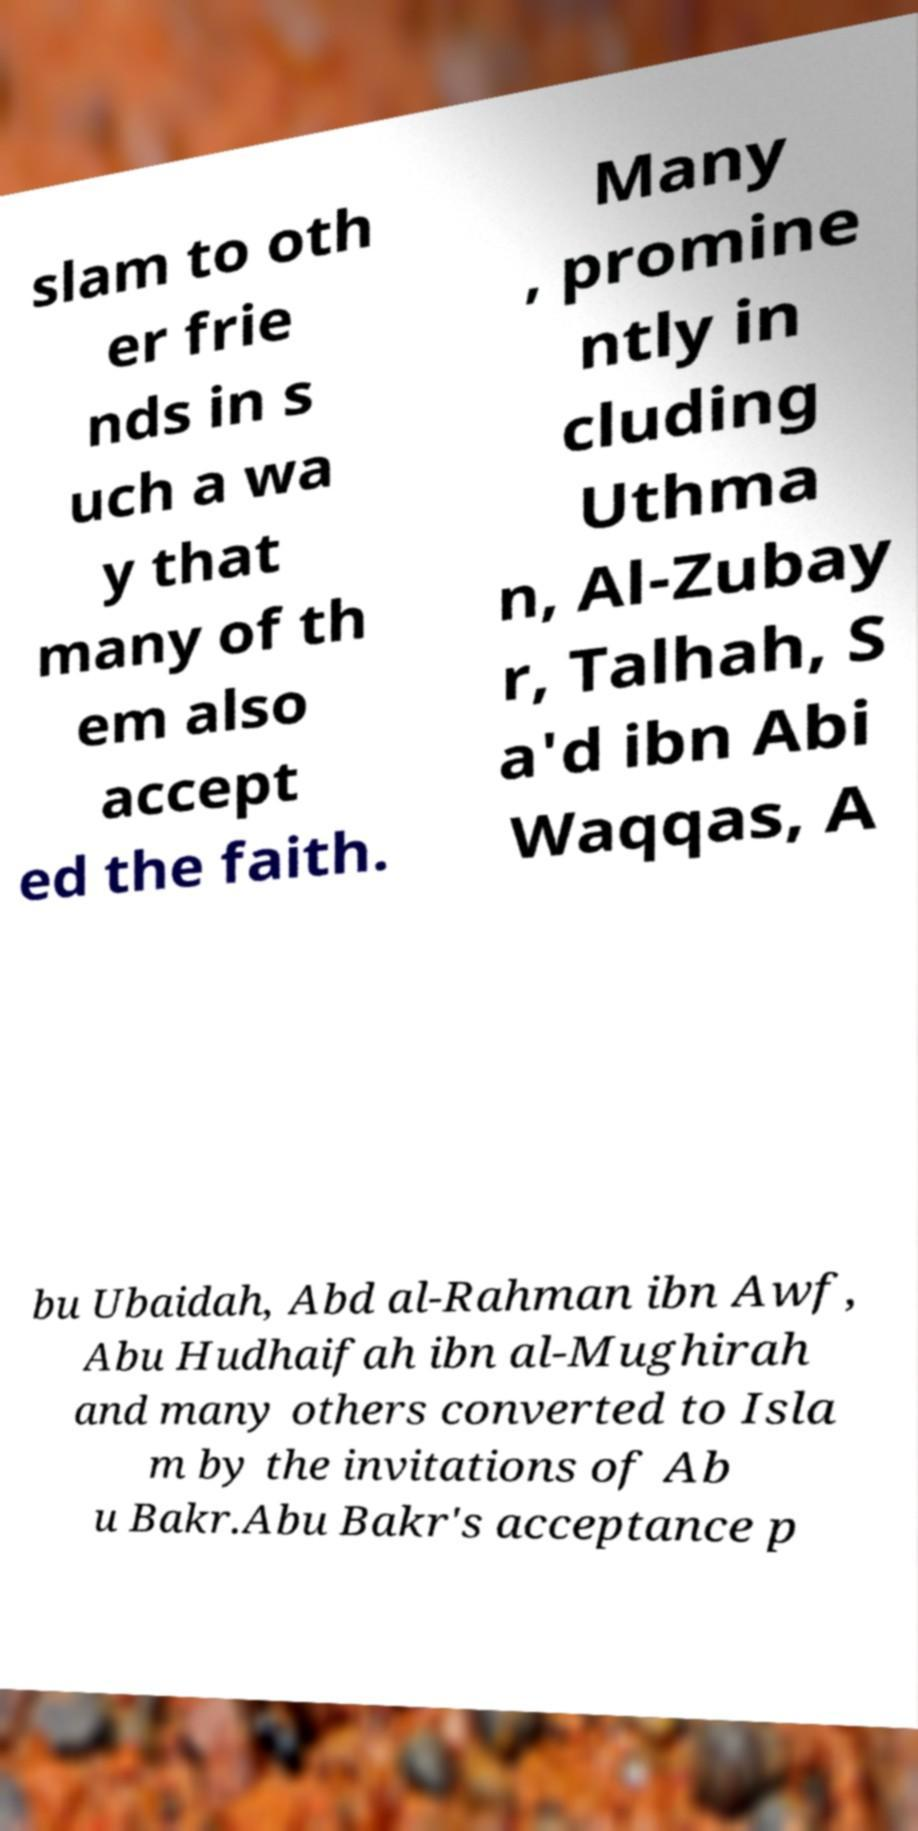What messages or text are displayed in this image? I need them in a readable, typed format. slam to oth er frie nds in s uch a wa y that many of th em also accept ed the faith. Many , promine ntly in cluding Uthma n, Al-Zubay r, Talhah, S a'd ibn Abi Waqqas, A bu Ubaidah, Abd al-Rahman ibn Awf, Abu Hudhaifah ibn al-Mughirah and many others converted to Isla m by the invitations of Ab u Bakr.Abu Bakr's acceptance p 